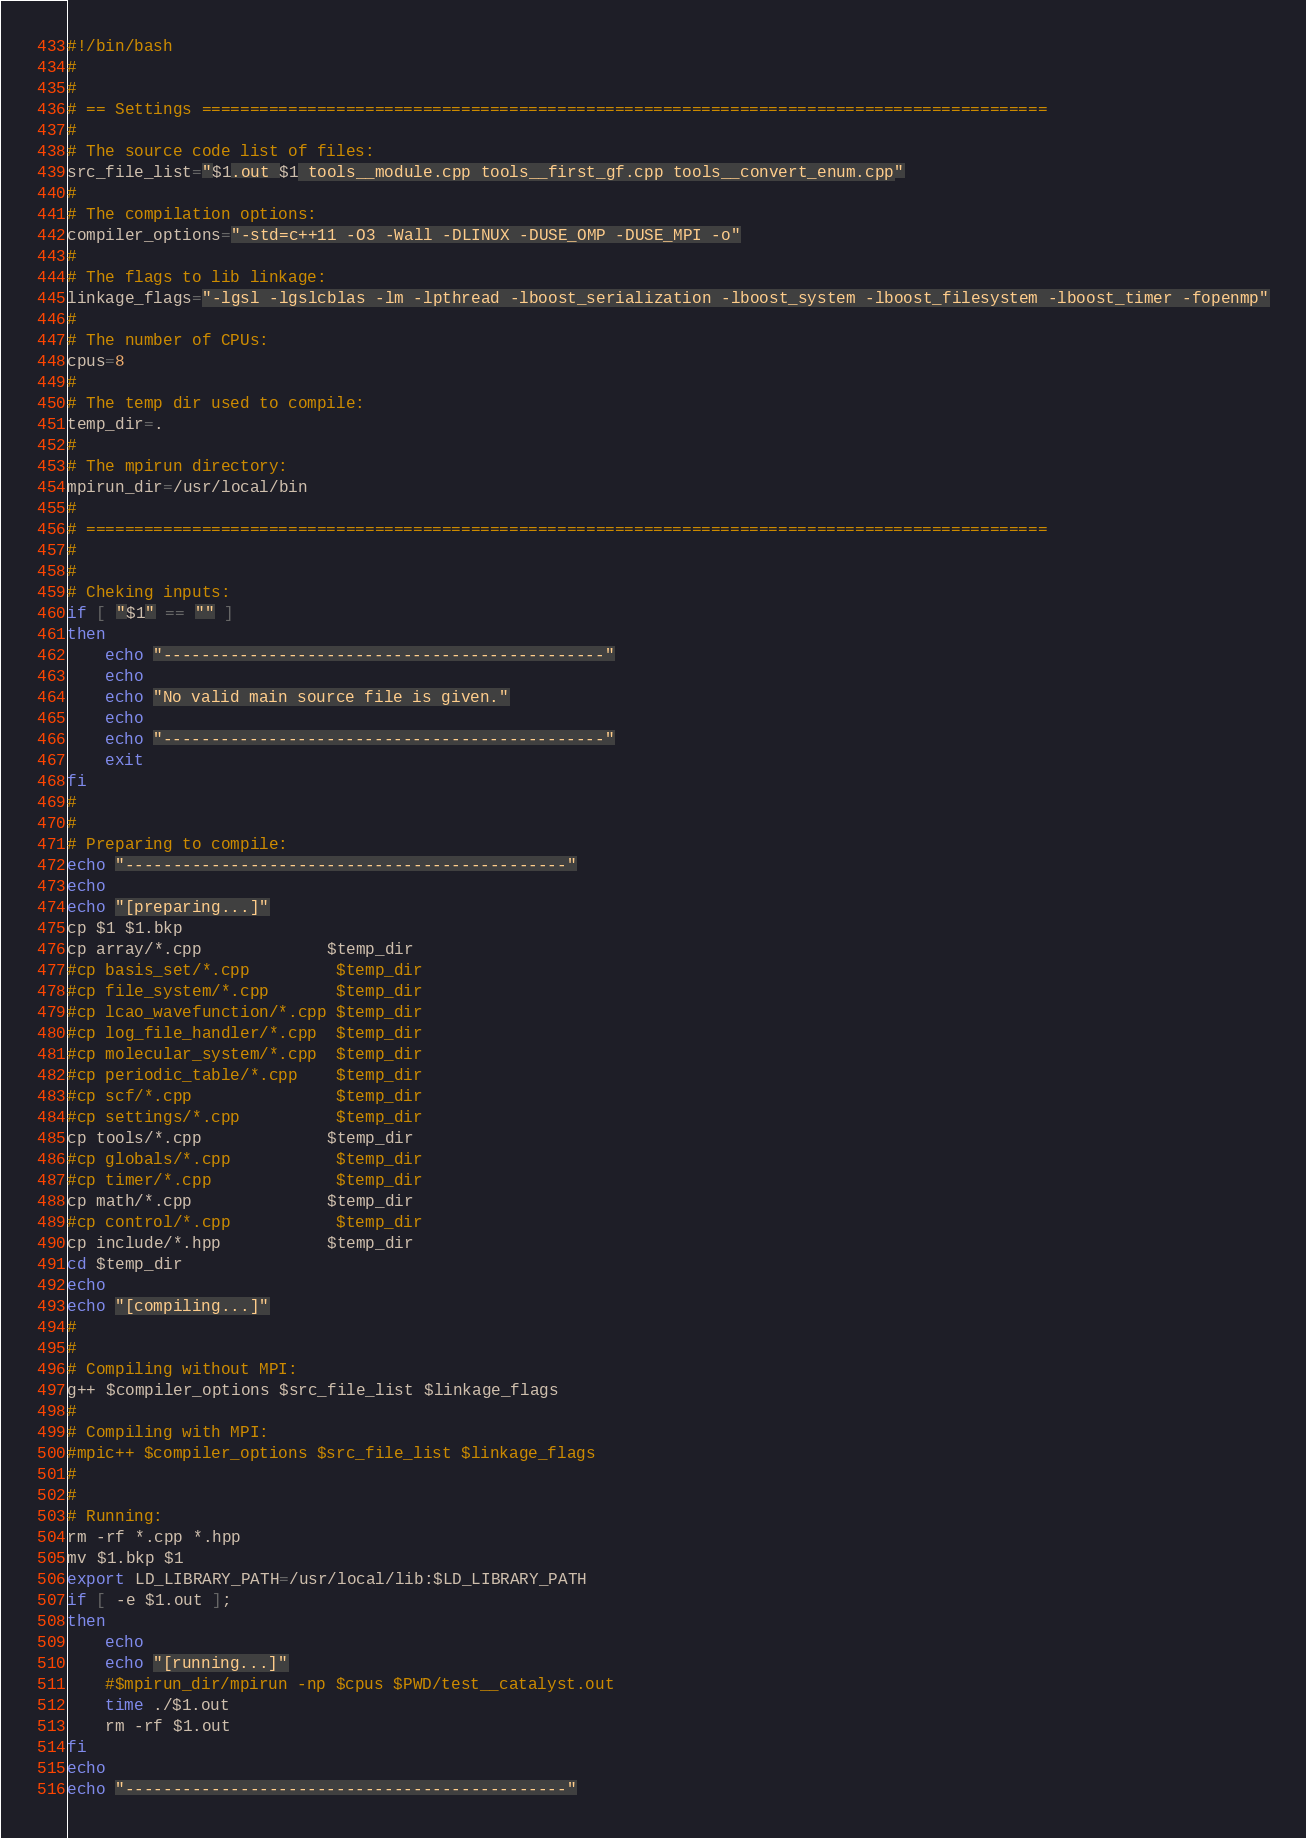Convert code to text. <code><loc_0><loc_0><loc_500><loc_500><_Bash_>#!/bin/bash
#
#
# == Settings ========================================================================================
#
# The source code list of files:
src_file_list="$1.out $1 tools__module.cpp tools__first_gf.cpp tools__convert_enum.cpp"
#
# The compilation options:
compiler_options="-std=c++11 -O3 -Wall -DLINUX -DUSE_OMP -DUSE_MPI -o"
#
# The flags to lib linkage:
linkage_flags="-lgsl -lgslcblas -lm -lpthread -lboost_serialization -lboost_system -lboost_filesystem -lboost_timer -fopenmp"
#
# The number of CPUs:
cpus=8
#
# The temp dir used to compile:
temp_dir=.
#
# The mpirun directory:
mpirun_dir=/usr/local/bin
#
# ====================================================================================================
#
#
# Cheking inputs:
if [ "$1" == "" ]
then
    echo "----------------------------------------------"
    echo
    echo "No valid main source file is given."
    echo
    echo "----------------------------------------------"
    exit
fi
#
#
# Preparing to compile:
echo "----------------------------------------------"
echo
echo "[preparing...]"
cp $1 $1.bkp
cp array/*.cpp             $temp_dir
#cp basis_set/*.cpp         $temp_dir
#cp file_system/*.cpp       $temp_dir
#cp lcao_wavefunction/*.cpp $temp_dir
#cp log_file_handler/*.cpp  $temp_dir
#cp molecular_system/*.cpp  $temp_dir
#cp periodic_table/*.cpp    $temp_dir
#cp scf/*.cpp               $temp_dir
#cp settings/*.cpp          $temp_dir
cp tools/*.cpp             $temp_dir
#cp globals/*.cpp           $temp_dir
#cp timer/*.cpp             $temp_dir
cp math/*.cpp              $temp_dir
#cp control/*.cpp           $temp_dir
cp include/*.hpp           $temp_dir
cd $temp_dir
echo
echo "[compiling...]"
#
#
# Compiling without MPI:
g++ $compiler_options $src_file_list $linkage_flags
#
# Compiling with MPI:
#mpic++ $compiler_options $src_file_list $linkage_flags
#
#
# Running:
rm -rf *.cpp *.hpp
mv $1.bkp $1
export LD_LIBRARY_PATH=/usr/local/lib:$LD_LIBRARY_PATH
if [ -e $1.out ];
then
    echo
    echo "[running...]"
    #$mpirun_dir/mpirun -np $cpus $PWD/test__catalyst.out
    time ./$1.out
    rm -rf $1.out
fi
echo
echo "----------------------------------------------"
</code> 